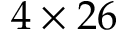Convert formula to latex. <formula><loc_0><loc_0><loc_500><loc_500>4 \times 2 6</formula> 